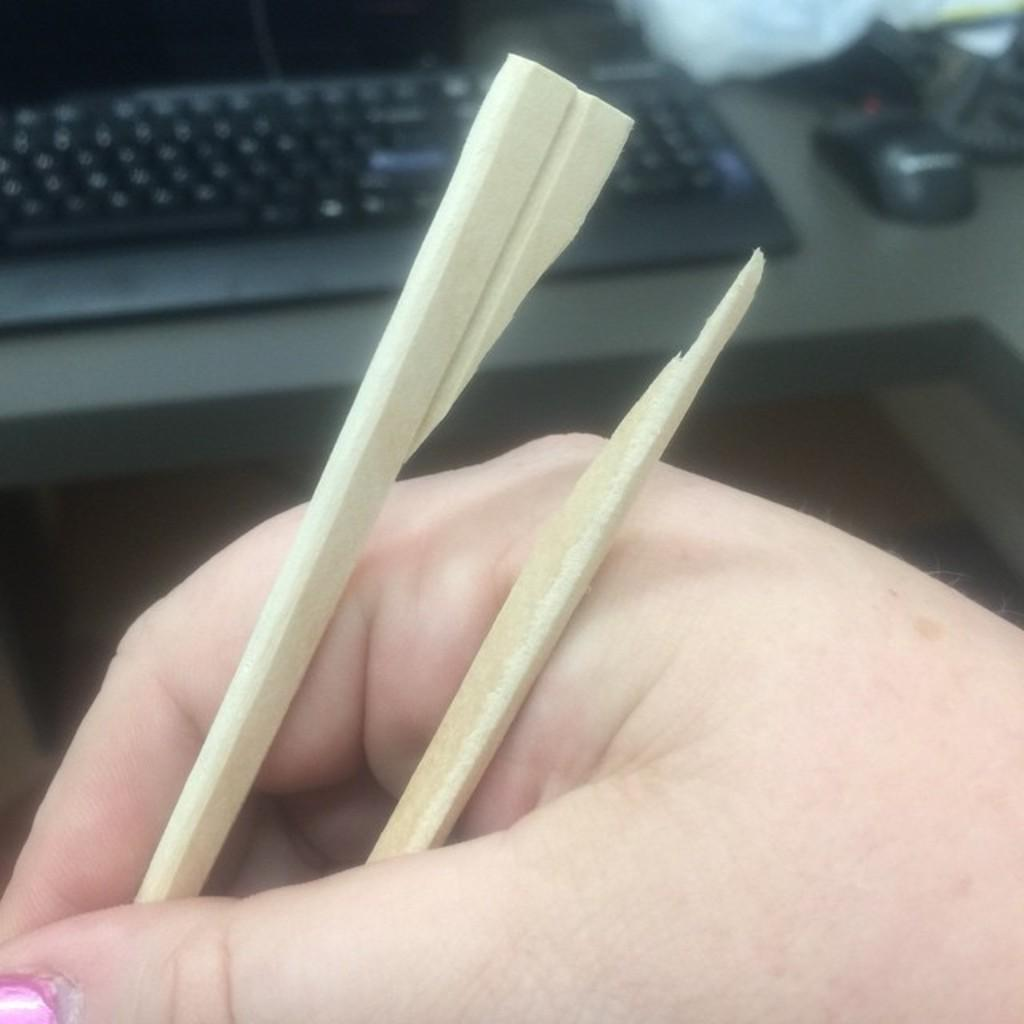What is being held in the hand that is visible in the image? There is a human's hand holding a slate pencil in the image. What type of device is visible in the image? A keyboard is visible in the image. What is used for input on the device in the image? A mouse is present in the image. What time of day is it in the image, and is there a kitty playing in the afternoon sun? The time of day is not mentioned in the image, and there is no kitty present in the image. 